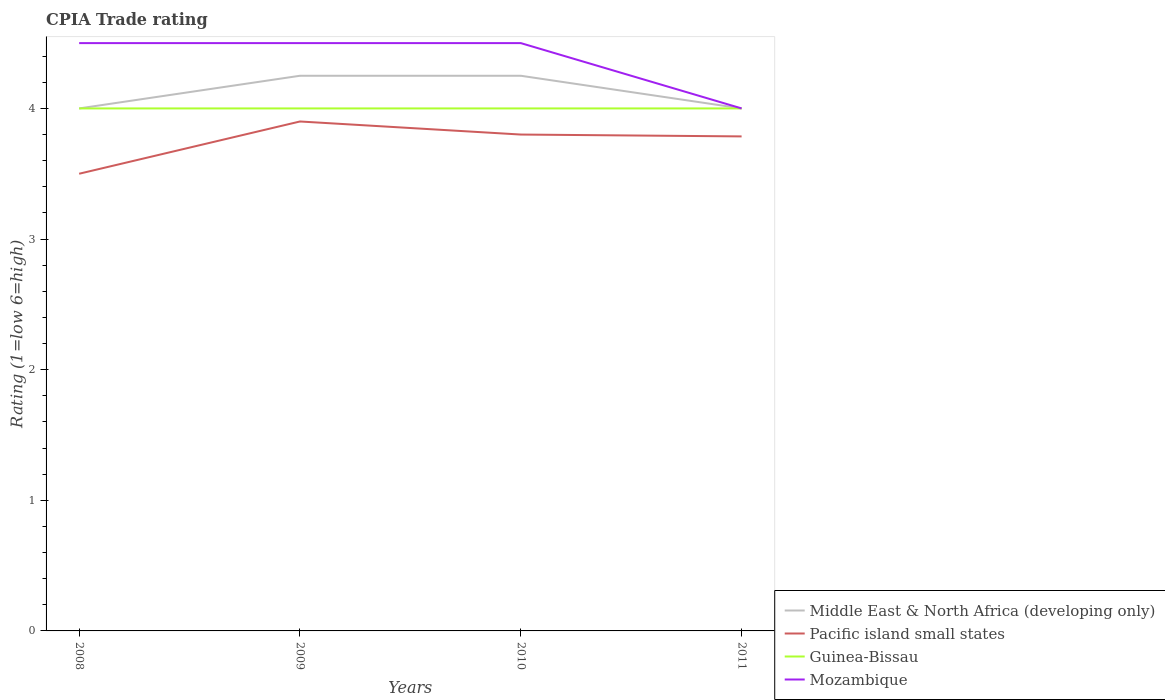How many different coloured lines are there?
Your answer should be compact. 4. In which year was the CPIA rating in Pacific island small states maximum?
Your answer should be very brief. 2008. What is the difference between the highest and the second highest CPIA rating in Guinea-Bissau?
Your answer should be very brief. 0. Is the CPIA rating in Mozambique strictly greater than the CPIA rating in Pacific island small states over the years?
Your answer should be very brief. No. What is the difference between two consecutive major ticks on the Y-axis?
Ensure brevity in your answer.  1. How many legend labels are there?
Give a very brief answer. 4. How are the legend labels stacked?
Provide a succinct answer. Vertical. What is the title of the graph?
Offer a very short reply. CPIA Trade rating. Does "Uzbekistan" appear as one of the legend labels in the graph?
Your answer should be very brief. No. What is the Rating (1=low 6=high) of Pacific island small states in 2008?
Provide a short and direct response. 3.5. What is the Rating (1=low 6=high) of Middle East & North Africa (developing only) in 2009?
Give a very brief answer. 4.25. What is the Rating (1=low 6=high) in Guinea-Bissau in 2009?
Offer a terse response. 4. What is the Rating (1=low 6=high) of Mozambique in 2009?
Your answer should be very brief. 4.5. What is the Rating (1=low 6=high) in Middle East & North Africa (developing only) in 2010?
Offer a terse response. 4.25. What is the Rating (1=low 6=high) of Mozambique in 2010?
Keep it short and to the point. 4.5. What is the Rating (1=low 6=high) in Pacific island small states in 2011?
Give a very brief answer. 3.79. What is the Rating (1=low 6=high) in Guinea-Bissau in 2011?
Your answer should be compact. 4. What is the Rating (1=low 6=high) in Mozambique in 2011?
Keep it short and to the point. 4. Across all years, what is the maximum Rating (1=low 6=high) in Middle East & North Africa (developing only)?
Your response must be concise. 4.25. Across all years, what is the minimum Rating (1=low 6=high) of Pacific island small states?
Give a very brief answer. 3.5. Across all years, what is the minimum Rating (1=low 6=high) of Guinea-Bissau?
Make the answer very short. 4. What is the total Rating (1=low 6=high) in Pacific island small states in the graph?
Give a very brief answer. 14.99. What is the difference between the Rating (1=low 6=high) in Middle East & North Africa (developing only) in 2008 and that in 2009?
Your response must be concise. -0.25. What is the difference between the Rating (1=low 6=high) of Pacific island small states in 2008 and that in 2009?
Offer a very short reply. -0.4. What is the difference between the Rating (1=low 6=high) in Pacific island small states in 2008 and that in 2010?
Your answer should be compact. -0.3. What is the difference between the Rating (1=low 6=high) of Guinea-Bissau in 2008 and that in 2010?
Give a very brief answer. 0. What is the difference between the Rating (1=low 6=high) of Middle East & North Africa (developing only) in 2008 and that in 2011?
Offer a very short reply. 0. What is the difference between the Rating (1=low 6=high) of Pacific island small states in 2008 and that in 2011?
Provide a short and direct response. -0.29. What is the difference between the Rating (1=low 6=high) of Mozambique in 2008 and that in 2011?
Make the answer very short. 0.5. What is the difference between the Rating (1=low 6=high) of Middle East & North Africa (developing only) in 2009 and that in 2010?
Offer a very short reply. 0. What is the difference between the Rating (1=low 6=high) in Middle East & North Africa (developing only) in 2009 and that in 2011?
Offer a terse response. 0.25. What is the difference between the Rating (1=low 6=high) in Pacific island small states in 2009 and that in 2011?
Ensure brevity in your answer.  0.11. What is the difference between the Rating (1=low 6=high) in Guinea-Bissau in 2009 and that in 2011?
Give a very brief answer. 0. What is the difference between the Rating (1=low 6=high) of Mozambique in 2009 and that in 2011?
Ensure brevity in your answer.  0.5. What is the difference between the Rating (1=low 6=high) of Pacific island small states in 2010 and that in 2011?
Give a very brief answer. 0.01. What is the difference between the Rating (1=low 6=high) in Middle East & North Africa (developing only) in 2008 and the Rating (1=low 6=high) in Pacific island small states in 2009?
Ensure brevity in your answer.  0.1. What is the difference between the Rating (1=low 6=high) of Middle East & North Africa (developing only) in 2008 and the Rating (1=low 6=high) of Guinea-Bissau in 2009?
Your response must be concise. 0. What is the difference between the Rating (1=low 6=high) of Middle East & North Africa (developing only) in 2008 and the Rating (1=low 6=high) of Mozambique in 2009?
Offer a terse response. -0.5. What is the difference between the Rating (1=low 6=high) of Pacific island small states in 2008 and the Rating (1=low 6=high) of Guinea-Bissau in 2009?
Give a very brief answer. -0.5. What is the difference between the Rating (1=low 6=high) in Middle East & North Africa (developing only) in 2008 and the Rating (1=low 6=high) in Pacific island small states in 2010?
Keep it short and to the point. 0.2. What is the difference between the Rating (1=low 6=high) in Middle East & North Africa (developing only) in 2008 and the Rating (1=low 6=high) in Guinea-Bissau in 2010?
Give a very brief answer. 0. What is the difference between the Rating (1=low 6=high) of Pacific island small states in 2008 and the Rating (1=low 6=high) of Guinea-Bissau in 2010?
Ensure brevity in your answer.  -0.5. What is the difference between the Rating (1=low 6=high) in Pacific island small states in 2008 and the Rating (1=low 6=high) in Mozambique in 2010?
Keep it short and to the point. -1. What is the difference between the Rating (1=low 6=high) in Middle East & North Africa (developing only) in 2008 and the Rating (1=low 6=high) in Pacific island small states in 2011?
Give a very brief answer. 0.21. What is the difference between the Rating (1=low 6=high) of Middle East & North Africa (developing only) in 2008 and the Rating (1=low 6=high) of Guinea-Bissau in 2011?
Your answer should be very brief. 0. What is the difference between the Rating (1=low 6=high) of Middle East & North Africa (developing only) in 2008 and the Rating (1=low 6=high) of Mozambique in 2011?
Give a very brief answer. 0. What is the difference between the Rating (1=low 6=high) in Pacific island small states in 2008 and the Rating (1=low 6=high) in Guinea-Bissau in 2011?
Provide a short and direct response. -0.5. What is the difference between the Rating (1=low 6=high) in Pacific island small states in 2008 and the Rating (1=low 6=high) in Mozambique in 2011?
Your answer should be compact. -0.5. What is the difference between the Rating (1=low 6=high) in Middle East & North Africa (developing only) in 2009 and the Rating (1=low 6=high) in Pacific island small states in 2010?
Ensure brevity in your answer.  0.45. What is the difference between the Rating (1=low 6=high) in Middle East & North Africa (developing only) in 2009 and the Rating (1=low 6=high) in Guinea-Bissau in 2010?
Your response must be concise. 0.25. What is the difference between the Rating (1=low 6=high) in Pacific island small states in 2009 and the Rating (1=low 6=high) in Guinea-Bissau in 2010?
Keep it short and to the point. -0.1. What is the difference between the Rating (1=low 6=high) of Guinea-Bissau in 2009 and the Rating (1=low 6=high) of Mozambique in 2010?
Give a very brief answer. -0.5. What is the difference between the Rating (1=low 6=high) of Middle East & North Africa (developing only) in 2009 and the Rating (1=low 6=high) of Pacific island small states in 2011?
Make the answer very short. 0.46. What is the difference between the Rating (1=low 6=high) of Guinea-Bissau in 2009 and the Rating (1=low 6=high) of Mozambique in 2011?
Provide a succinct answer. 0. What is the difference between the Rating (1=low 6=high) of Middle East & North Africa (developing only) in 2010 and the Rating (1=low 6=high) of Pacific island small states in 2011?
Your response must be concise. 0.46. What is the difference between the Rating (1=low 6=high) in Pacific island small states in 2010 and the Rating (1=low 6=high) in Guinea-Bissau in 2011?
Give a very brief answer. -0.2. What is the difference between the Rating (1=low 6=high) in Guinea-Bissau in 2010 and the Rating (1=low 6=high) in Mozambique in 2011?
Offer a terse response. 0. What is the average Rating (1=low 6=high) in Middle East & North Africa (developing only) per year?
Your answer should be very brief. 4.12. What is the average Rating (1=low 6=high) of Pacific island small states per year?
Offer a terse response. 3.75. What is the average Rating (1=low 6=high) of Guinea-Bissau per year?
Your answer should be very brief. 4. What is the average Rating (1=low 6=high) of Mozambique per year?
Ensure brevity in your answer.  4.38. In the year 2008, what is the difference between the Rating (1=low 6=high) in Middle East & North Africa (developing only) and Rating (1=low 6=high) in Guinea-Bissau?
Your response must be concise. 0. In the year 2008, what is the difference between the Rating (1=low 6=high) in Pacific island small states and Rating (1=low 6=high) in Guinea-Bissau?
Your answer should be compact. -0.5. In the year 2008, what is the difference between the Rating (1=low 6=high) of Guinea-Bissau and Rating (1=low 6=high) of Mozambique?
Your response must be concise. -0.5. In the year 2009, what is the difference between the Rating (1=low 6=high) of Middle East & North Africa (developing only) and Rating (1=low 6=high) of Mozambique?
Ensure brevity in your answer.  -0.25. In the year 2009, what is the difference between the Rating (1=low 6=high) of Pacific island small states and Rating (1=low 6=high) of Guinea-Bissau?
Provide a short and direct response. -0.1. In the year 2009, what is the difference between the Rating (1=low 6=high) in Pacific island small states and Rating (1=low 6=high) in Mozambique?
Ensure brevity in your answer.  -0.6. In the year 2010, what is the difference between the Rating (1=low 6=high) of Middle East & North Africa (developing only) and Rating (1=low 6=high) of Pacific island small states?
Your response must be concise. 0.45. In the year 2010, what is the difference between the Rating (1=low 6=high) in Middle East & North Africa (developing only) and Rating (1=low 6=high) in Guinea-Bissau?
Offer a terse response. 0.25. In the year 2010, what is the difference between the Rating (1=low 6=high) in Middle East & North Africa (developing only) and Rating (1=low 6=high) in Mozambique?
Your response must be concise. -0.25. In the year 2010, what is the difference between the Rating (1=low 6=high) of Pacific island small states and Rating (1=low 6=high) of Guinea-Bissau?
Your answer should be compact. -0.2. In the year 2010, what is the difference between the Rating (1=low 6=high) of Pacific island small states and Rating (1=low 6=high) of Mozambique?
Your answer should be compact. -0.7. In the year 2011, what is the difference between the Rating (1=low 6=high) in Middle East & North Africa (developing only) and Rating (1=low 6=high) in Pacific island small states?
Give a very brief answer. 0.21. In the year 2011, what is the difference between the Rating (1=low 6=high) of Middle East & North Africa (developing only) and Rating (1=low 6=high) of Guinea-Bissau?
Offer a terse response. 0. In the year 2011, what is the difference between the Rating (1=low 6=high) in Pacific island small states and Rating (1=low 6=high) in Guinea-Bissau?
Give a very brief answer. -0.21. In the year 2011, what is the difference between the Rating (1=low 6=high) of Pacific island small states and Rating (1=low 6=high) of Mozambique?
Offer a terse response. -0.21. In the year 2011, what is the difference between the Rating (1=low 6=high) in Guinea-Bissau and Rating (1=low 6=high) in Mozambique?
Ensure brevity in your answer.  0. What is the ratio of the Rating (1=low 6=high) in Middle East & North Africa (developing only) in 2008 to that in 2009?
Your answer should be very brief. 0.94. What is the ratio of the Rating (1=low 6=high) of Pacific island small states in 2008 to that in 2009?
Provide a short and direct response. 0.9. What is the ratio of the Rating (1=low 6=high) of Middle East & North Africa (developing only) in 2008 to that in 2010?
Provide a succinct answer. 0.94. What is the ratio of the Rating (1=low 6=high) in Pacific island small states in 2008 to that in 2010?
Offer a very short reply. 0.92. What is the ratio of the Rating (1=low 6=high) in Mozambique in 2008 to that in 2010?
Give a very brief answer. 1. What is the ratio of the Rating (1=low 6=high) of Middle East & North Africa (developing only) in 2008 to that in 2011?
Your answer should be compact. 1. What is the ratio of the Rating (1=low 6=high) in Pacific island small states in 2008 to that in 2011?
Keep it short and to the point. 0.92. What is the ratio of the Rating (1=low 6=high) in Guinea-Bissau in 2008 to that in 2011?
Your response must be concise. 1. What is the ratio of the Rating (1=low 6=high) of Middle East & North Africa (developing only) in 2009 to that in 2010?
Your answer should be very brief. 1. What is the ratio of the Rating (1=low 6=high) in Pacific island small states in 2009 to that in 2010?
Provide a short and direct response. 1.03. What is the ratio of the Rating (1=low 6=high) in Mozambique in 2009 to that in 2010?
Offer a very short reply. 1. What is the ratio of the Rating (1=low 6=high) of Pacific island small states in 2009 to that in 2011?
Ensure brevity in your answer.  1.03. What is the ratio of the Rating (1=low 6=high) in Guinea-Bissau in 2010 to that in 2011?
Provide a succinct answer. 1. What is the ratio of the Rating (1=low 6=high) of Mozambique in 2010 to that in 2011?
Keep it short and to the point. 1.12. What is the difference between the highest and the second highest Rating (1=low 6=high) of Middle East & North Africa (developing only)?
Your response must be concise. 0. What is the difference between the highest and the second highest Rating (1=low 6=high) in Mozambique?
Make the answer very short. 0. What is the difference between the highest and the lowest Rating (1=low 6=high) in Middle East & North Africa (developing only)?
Provide a short and direct response. 0.25. What is the difference between the highest and the lowest Rating (1=low 6=high) of Pacific island small states?
Offer a very short reply. 0.4. What is the difference between the highest and the lowest Rating (1=low 6=high) of Guinea-Bissau?
Offer a terse response. 0. 